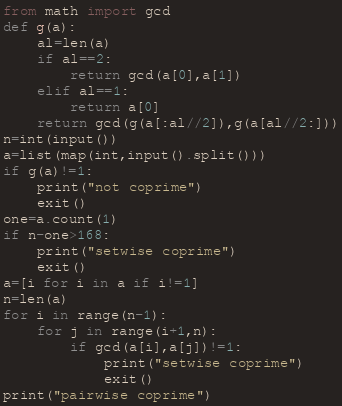Convert code to text. <code><loc_0><loc_0><loc_500><loc_500><_Python_>from math import gcd
def g(a):
    al=len(a)
    if al==2:
        return gcd(a[0],a[1])
    elif al==1:
        return a[0]
    return gcd(g(a[:al//2]),g(a[al//2:]))
n=int(input())
a=list(map(int,input().split()))
if g(a)!=1:
    print("not coprime")
    exit()
one=a.count(1)
if n-one>168:
    print("setwise coprime")
    exit()
a=[i for i in a if i!=1]
n=len(a)
for i in range(n-1):
    for j in range(i+1,n):
        if gcd(a[i],a[j])!=1:
            print("setwise coprime")
            exit()
print("pairwise coprime")</code> 